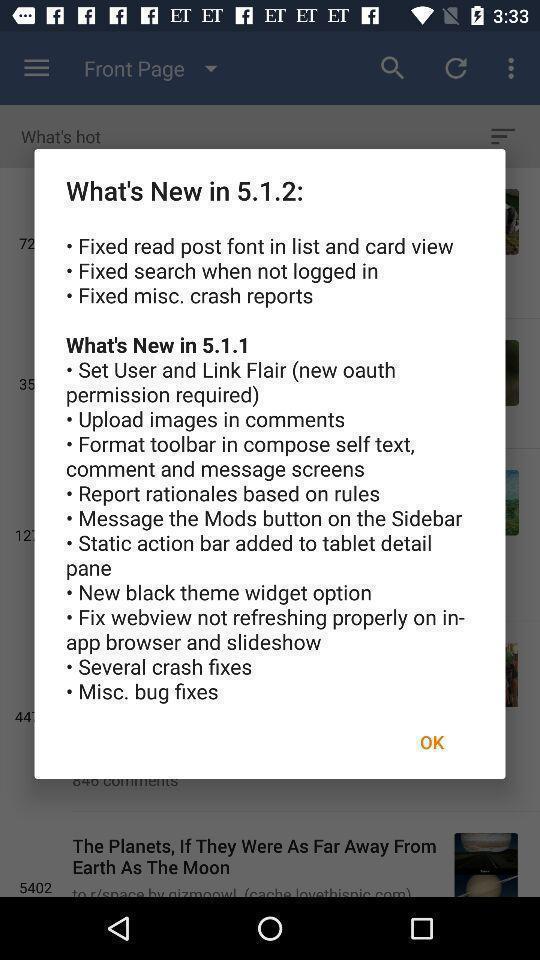Describe this image in words. Pop up showing information. 